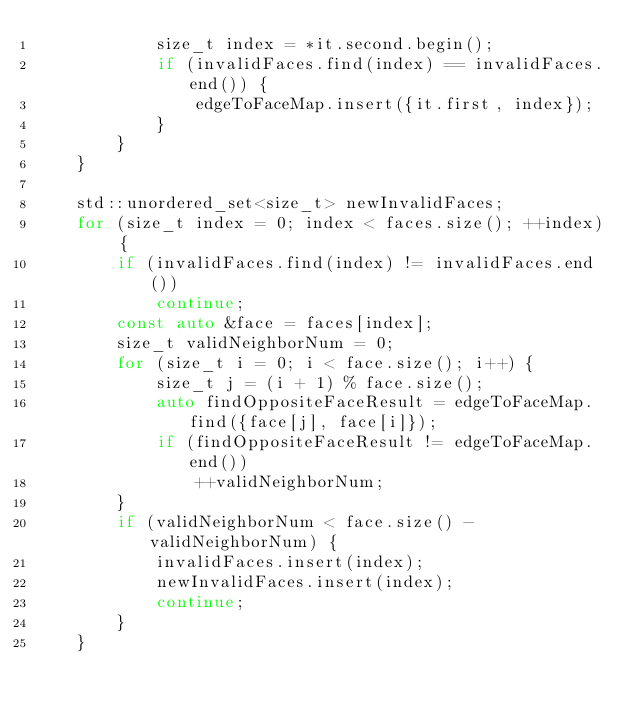<code> <loc_0><loc_0><loc_500><loc_500><_C++_>            size_t index = *it.second.begin();
            if (invalidFaces.find(index) == invalidFaces.end()) {
                edgeToFaceMap.insert({it.first, index});
            }
        }
    }
    
    std::unordered_set<size_t> newInvalidFaces;
    for (size_t index = 0; index < faces.size(); ++index) {
        if (invalidFaces.find(index) != invalidFaces.end())
            continue;
        const auto &face = faces[index];
        size_t validNeighborNum = 0;
        for (size_t i = 0; i < face.size(); i++) {
            size_t j = (i + 1) % face.size();
            auto findOppositeFaceResult = edgeToFaceMap.find({face[j], face[i]});
            if (findOppositeFaceResult != edgeToFaceMap.end())
                ++validNeighborNum;
        }
        if (validNeighborNum < face.size() - validNeighborNum) {
            invalidFaces.insert(index);
            newInvalidFaces.insert(index);
            continue;
        }
    }
    </code> 